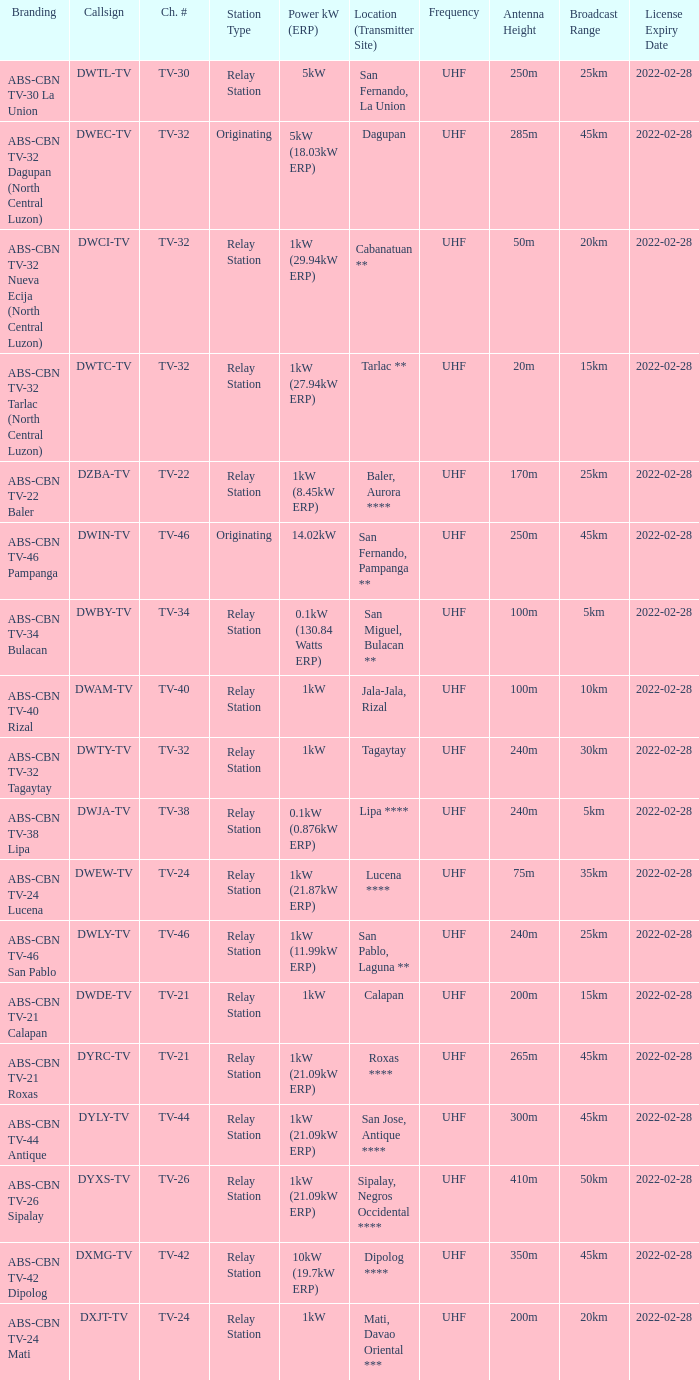How many brandings are there where the Power kW (ERP) is 1kW (29.94kW ERP)? 1.0. 